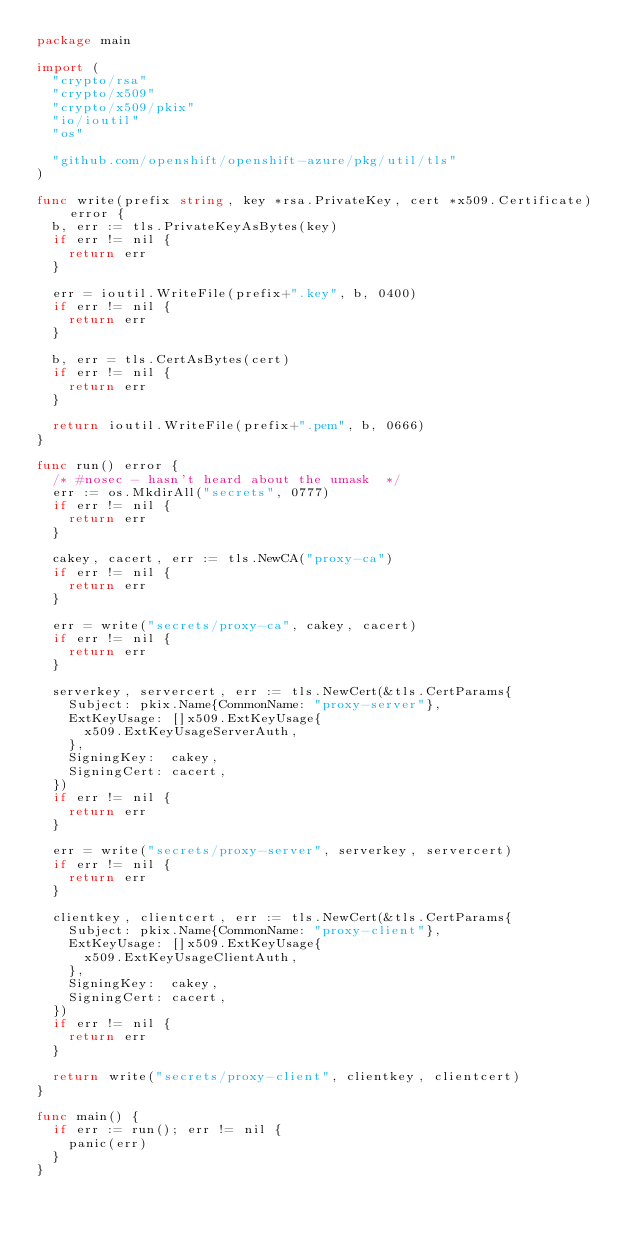<code> <loc_0><loc_0><loc_500><loc_500><_Go_>package main

import (
	"crypto/rsa"
	"crypto/x509"
	"crypto/x509/pkix"
	"io/ioutil"
	"os"

	"github.com/openshift/openshift-azure/pkg/util/tls"
)

func write(prefix string, key *rsa.PrivateKey, cert *x509.Certificate) error {
	b, err := tls.PrivateKeyAsBytes(key)
	if err != nil {
		return err
	}

	err = ioutil.WriteFile(prefix+".key", b, 0400)
	if err != nil {
		return err
	}

	b, err = tls.CertAsBytes(cert)
	if err != nil {
		return err
	}

	return ioutil.WriteFile(prefix+".pem", b, 0666)
}

func run() error {
	/* #nosec - hasn't heard about the umask  */
	err := os.MkdirAll("secrets", 0777)
	if err != nil {
		return err
	}

	cakey, cacert, err := tls.NewCA("proxy-ca")
	if err != nil {
		return err
	}

	err = write("secrets/proxy-ca", cakey, cacert)
	if err != nil {
		return err
	}

	serverkey, servercert, err := tls.NewCert(&tls.CertParams{
		Subject: pkix.Name{CommonName: "proxy-server"},
		ExtKeyUsage: []x509.ExtKeyUsage{
			x509.ExtKeyUsageServerAuth,
		},
		SigningKey:  cakey,
		SigningCert: cacert,
	})
	if err != nil {
		return err
	}

	err = write("secrets/proxy-server", serverkey, servercert)
	if err != nil {
		return err
	}

	clientkey, clientcert, err := tls.NewCert(&tls.CertParams{
		Subject: pkix.Name{CommonName: "proxy-client"},
		ExtKeyUsage: []x509.ExtKeyUsage{
			x509.ExtKeyUsageClientAuth,
		},
		SigningKey:  cakey,
		SigningCert: cacert,
	})
	if err != nil {
		return err
	}

	return write("secrets/proxy-client", clientkey, clientcert)
}

func main() {
	if err := run(); err != nil {
		panic(err)
	}
}
</code> 